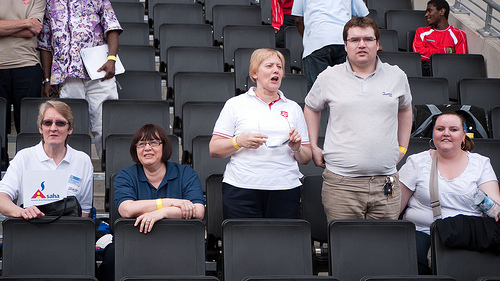<image>
Is there a woman behind the chair? Yes. From this viewpoint, the woman is positioned behind the chair, with the chair partially or fully occluding the woman. 